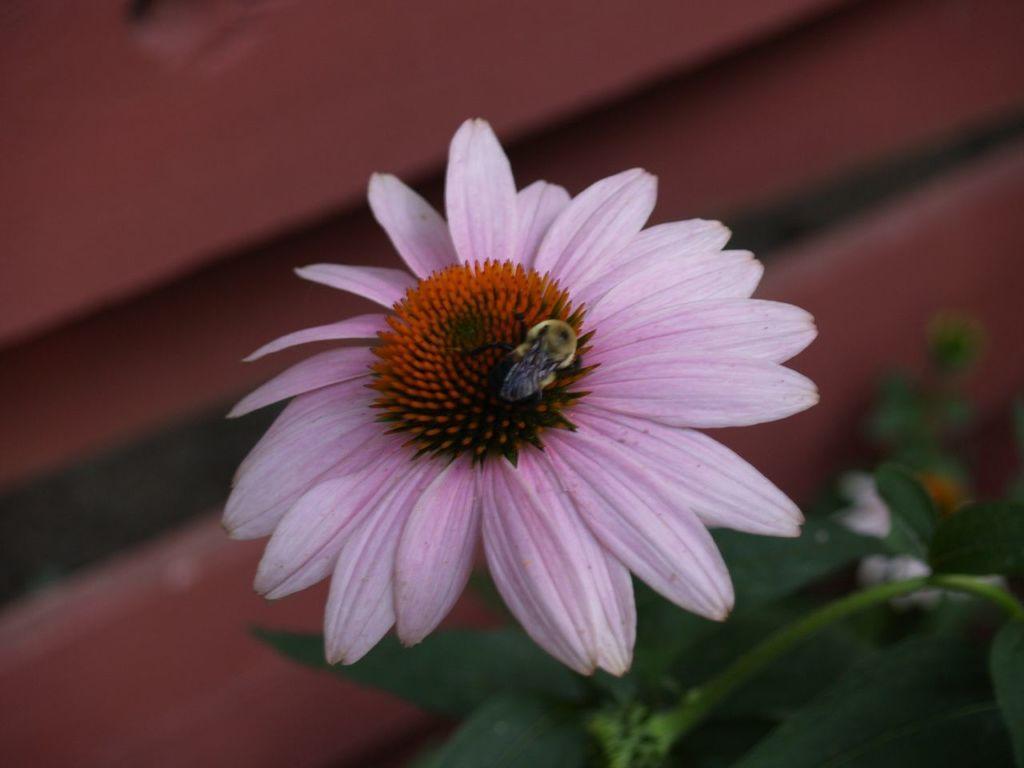In one or two sentences, can you explain what this image depicts? In this image I see a flower which is of pink and orange in color and I see an insect over here. In the background I see the leaves and it is brown over here. 